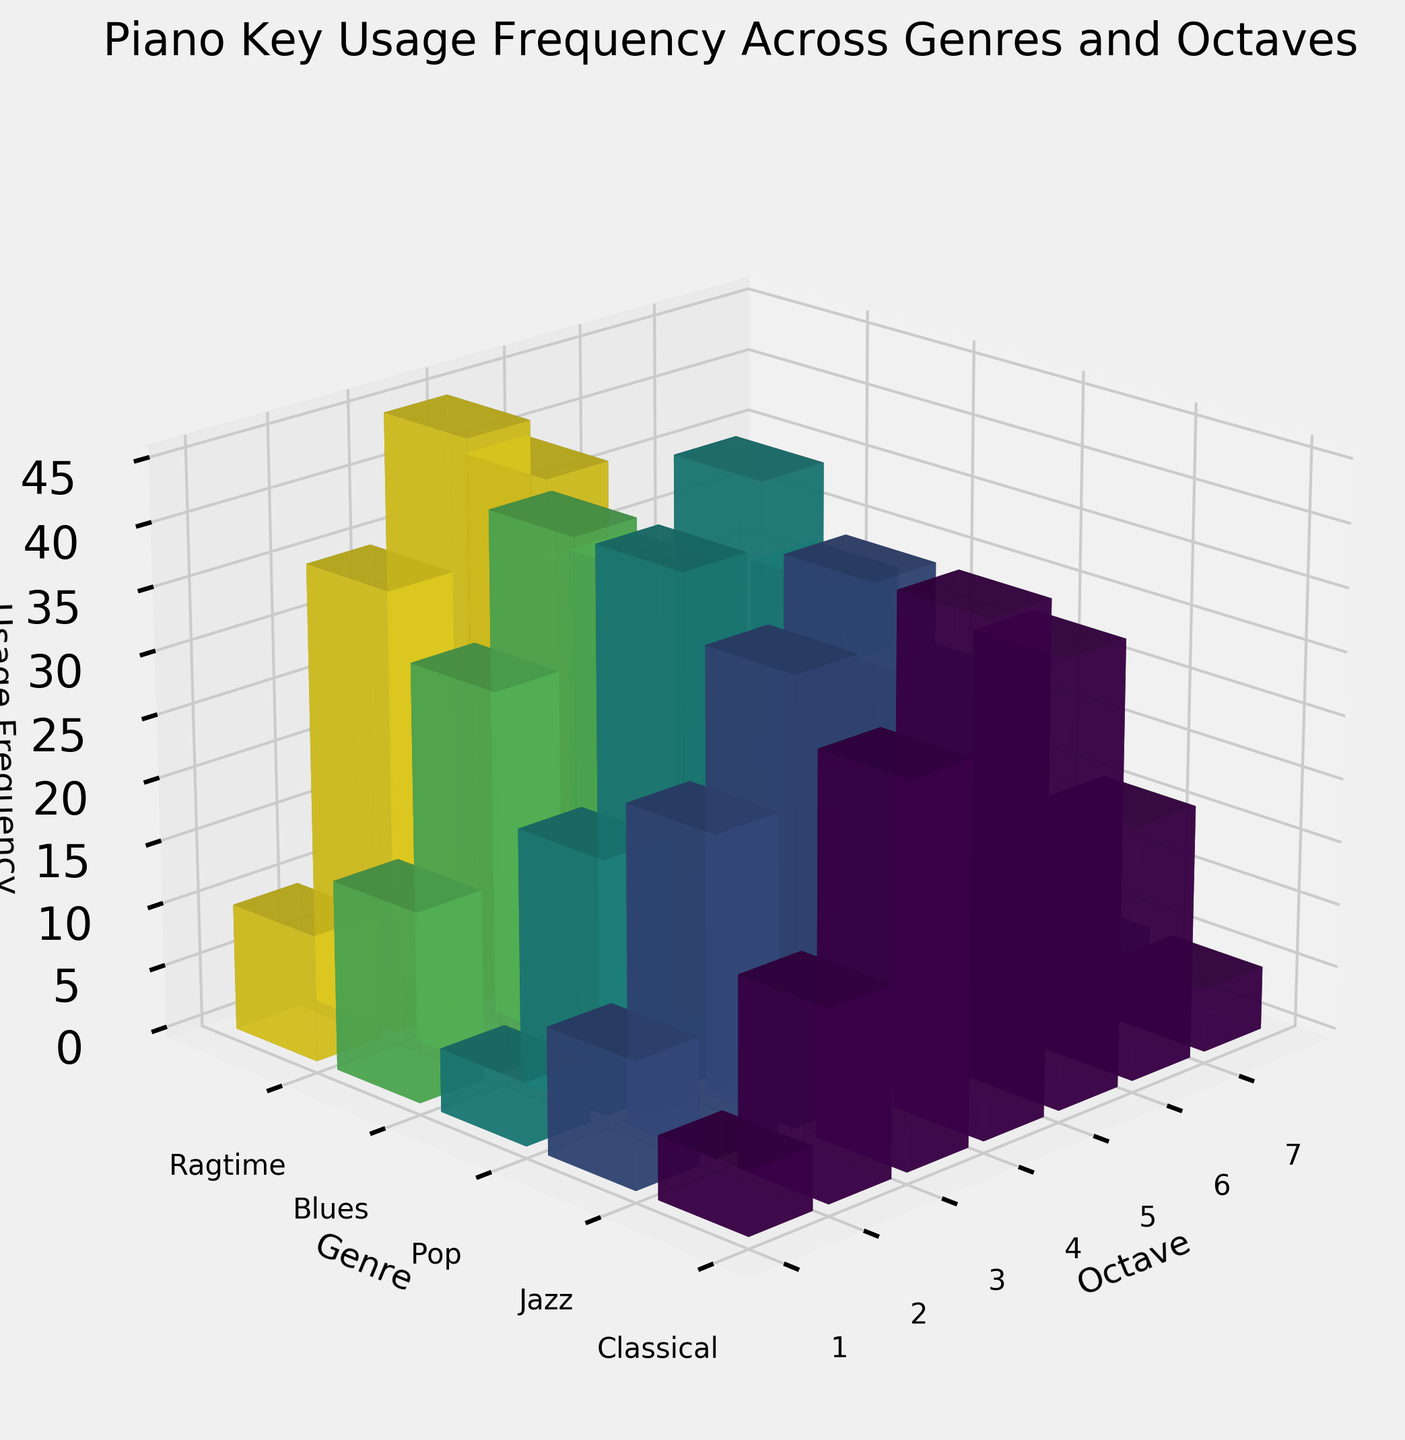What is the title of the figure? The title of the figure is clearly written at the top of the plot. It helps to understand what the plot is about.
Answer: Piano Key Usage Frequency Across Genres and Octaves Which genre has the highest usage frequency in octave 3? To find this, look at the bars corresponding to octave 3 for each genre. Identify which bar is the tallest.
Answer: Ragtime What is the average usage frequency of octave 4 across all genres? Calculate the sum of usage frequencies of octave 4 for all genres and divide it by the number of genres (5). (40 + 40 + 45 + 35 + 40) = 200, so the average is 200 / 5 = 40.
Answer: 40 Which genre uses the lowest frequency in octave 7? Find the bar representing octave 7 for each genre and identify the shortest one.
Answer: Pop and Blues What is the difference in usage frequency between octave 1 and octave 7 in Jazz? Subtract the usage frequency of octave 7 from that of octave 1 in Jazz. (10 - 5) = 5.
Answer: 5 What is the most frequently used octave in the Pop genre? Look at all the bars representing the Pop genre and find the tallest one.
Answer: Octave 4 Which genre has the most similar usage frequency distribution to Classical? Compare the bar heights for each octave between Classical and other genres to identify which has a similar pattern.
Answer: Jazz What is the total usage frequency for all octaves in the Blues genre? Add up the usage frequencies of all octaves in the Blues genre. (15 + 30 + 40 + 35 + 25 + 10 + 2) = 157.
Answer: 157 How does the usage frequency of octave 5 in Classical compare to Ragtime? Compare the heights of the bars representing octave 5 for Classical and Ragtime. Analyze which one is taller or if they are equal.
Answer: Classical is higher Is there any octave that is used uniformly across all genres? Examine the bars for each octave across all genres and see if any octave has the same height bars across the genres.
Answer: No 